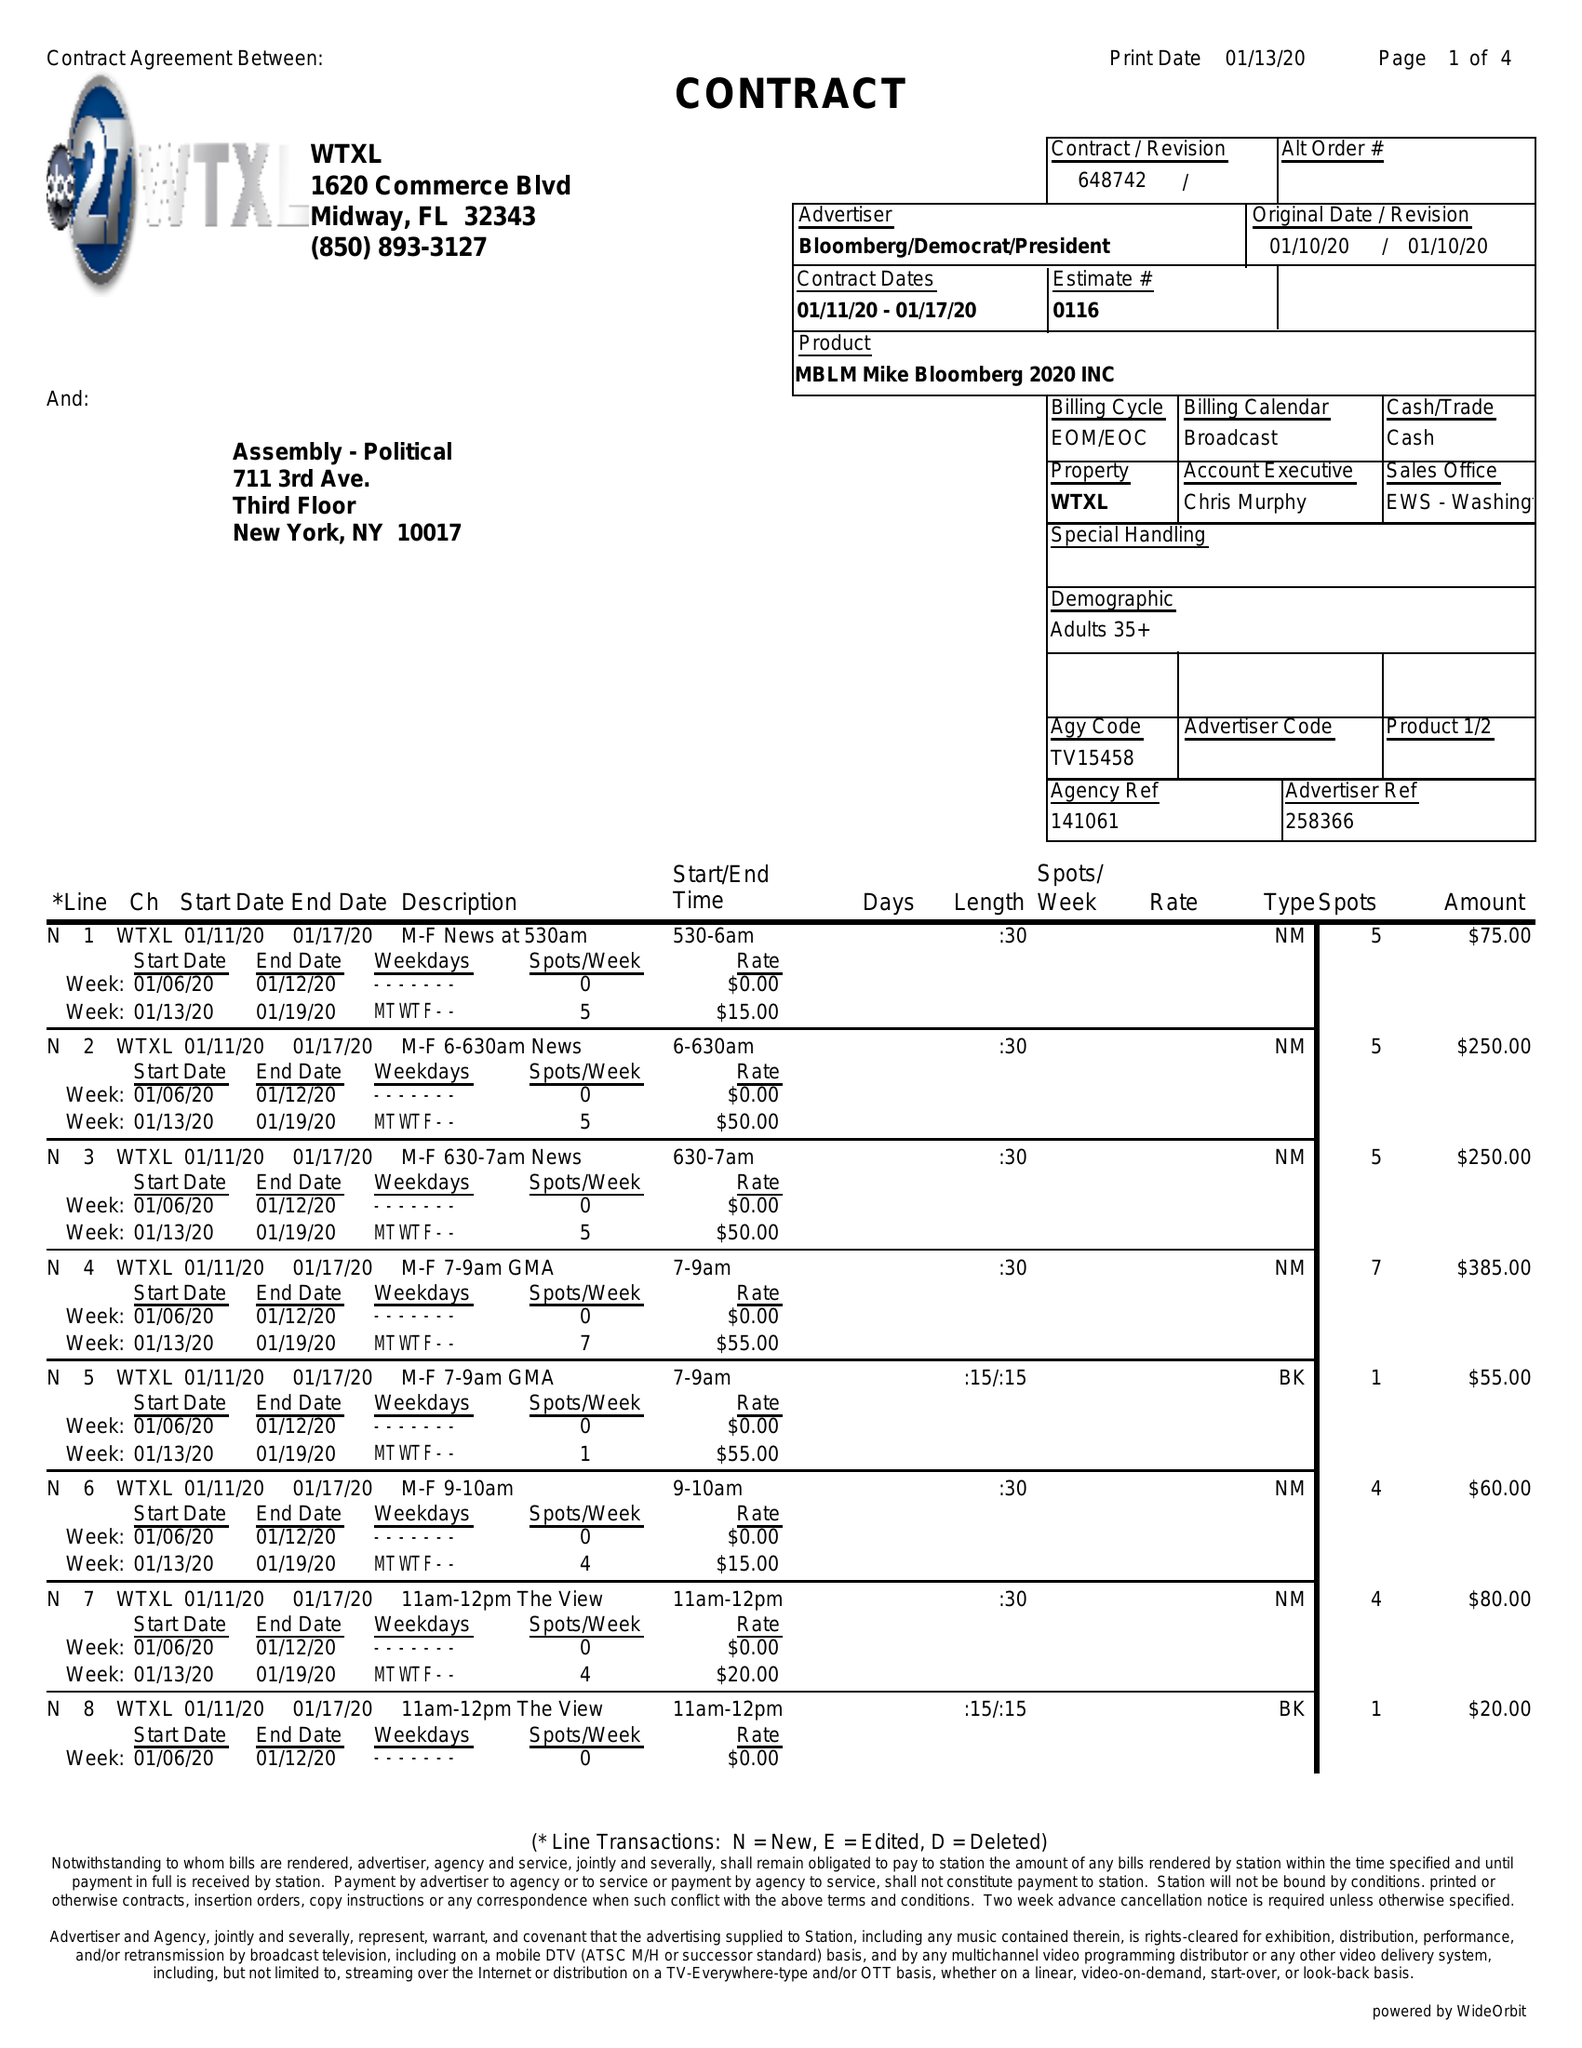What is the value for the gross_amount?
Answer the question using a single word or phrase. 7000.00 